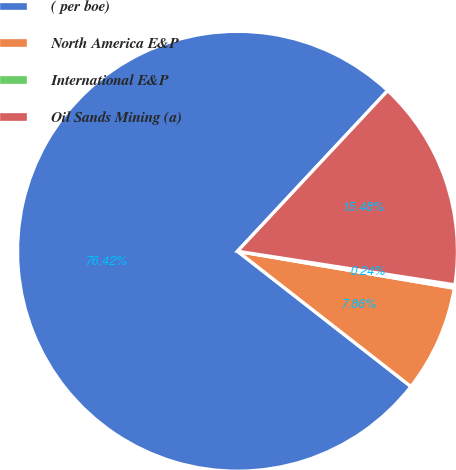Convert chart to OTSL. <chart><loc_0><loc_0><loc_500><loc_500><pie_chart><fcel>( per boe)<fcel>North America E&P<fcel>International E&P<fcel>Oil Sands Mining (a)<nl><fcel>76.42%<fcel>7.86%<fcel>0.24%<fcel>15.48%<nl></chart> 